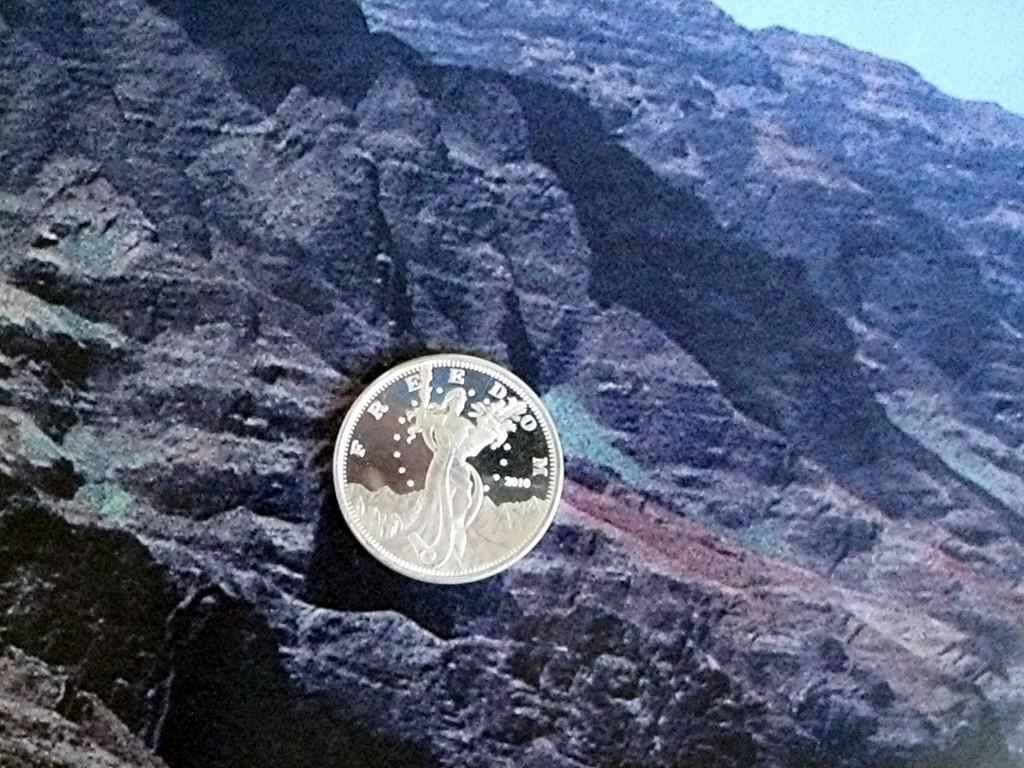Provide a one-sentence caption for the provided image. Freedom 2010 is etched into the face of this shiny coin. 